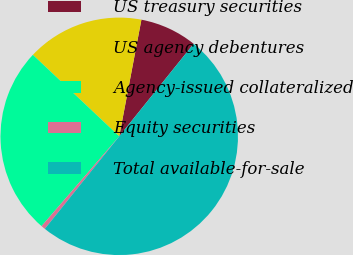Convert chart to OTSL. <chart><loc_0><loc_0><loc_500><loc_500><pie_chart><fcel>US treasury securities<fcel>US agency debentures<fcel>Agency-issued collateralized<fcel>Equity securities<fcel>Total available-for-sale<nl><fcel>7.79%<fcel>15.95%<fcel>25.69%<fcel>0.57%<fcel>50.0%<nl></chart> 